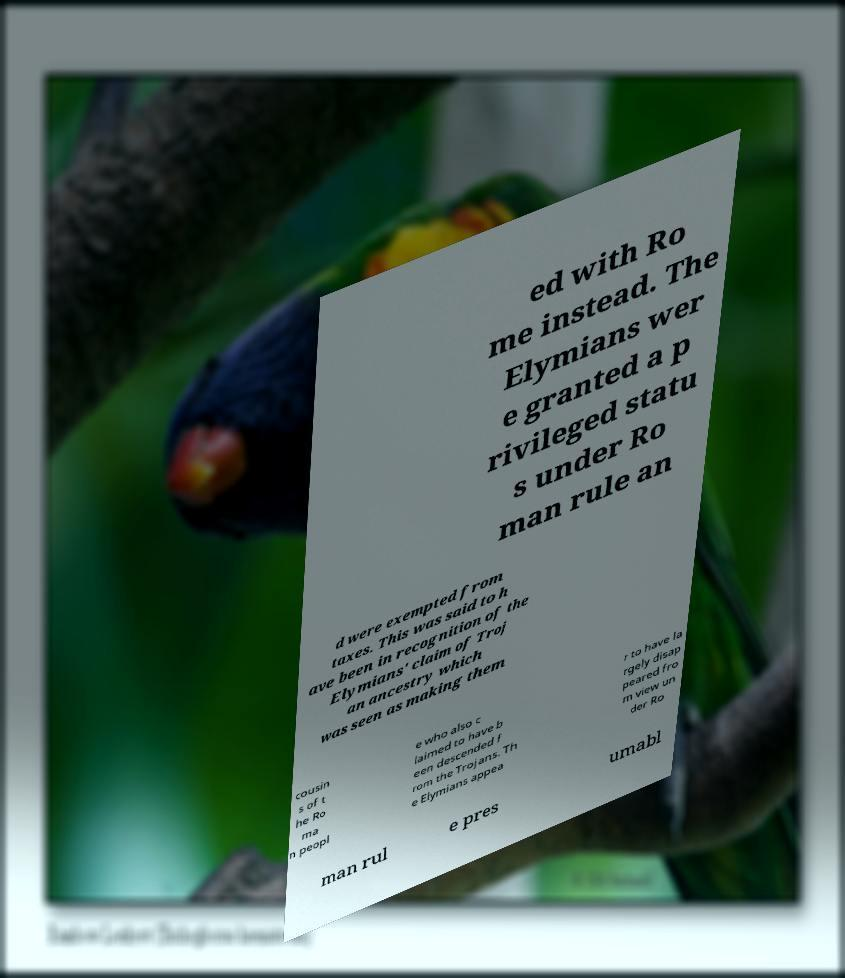There's text embedded in this image that I need extracted. Can you transcribe it verbatim? ed with Ro me instead. The Elymians wer e granted a p rivileged statu s under Ro man rule an d were exempted from taxes. This was said to h ave been in recognition of the Elymians' claim of Troj an ancestry which was seen as making them cousin s of t he Ro ma n peopl e who also c laimed to have b een descended f rom the Trojans. Th e Elymians appea r to have la rgely disap peared fro m view un der Ro man rul e pres umabl 